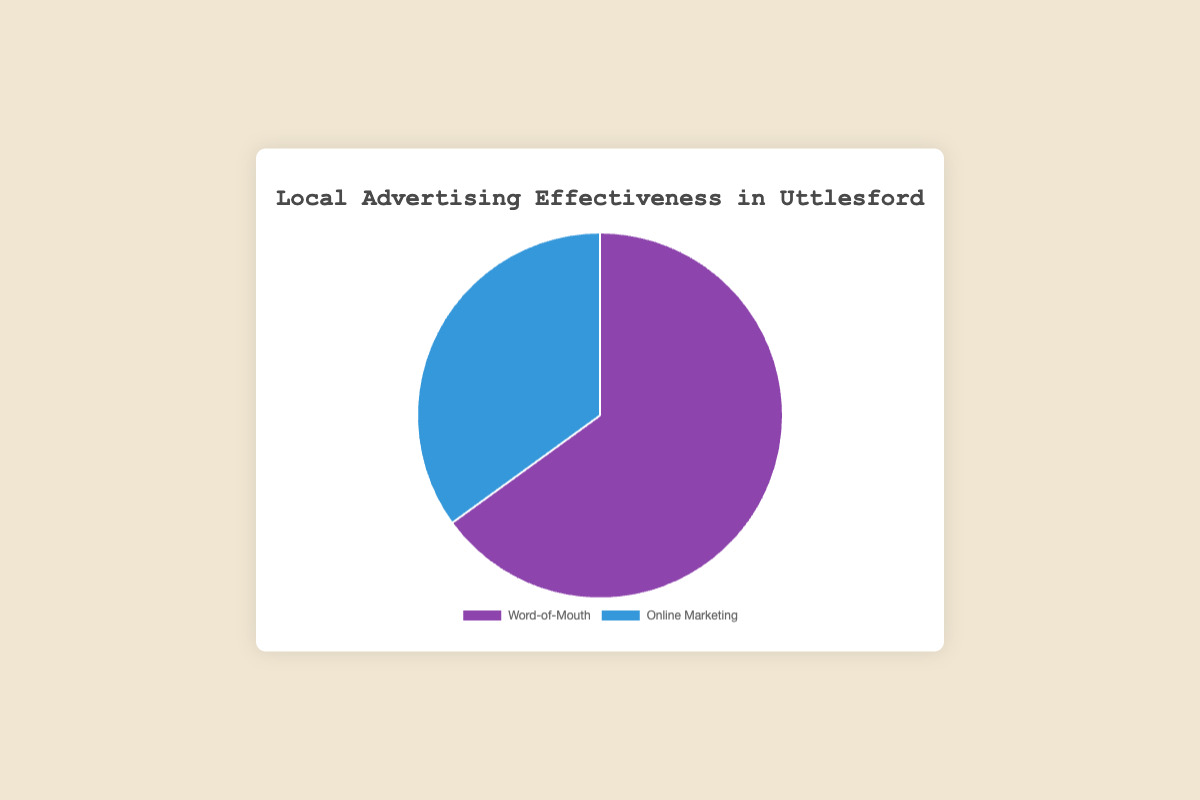What percentage of the effectiveness does Word-of-Mouth account for? The pie chart shows two categories: Word-of-Mouth and Online Marketing. Word-of-Mouth accounts for 65% of the effectiveness.
Answer: 65% How does the effectiveness of Online Marketing compare to Word-of-Mouth? The pie chart indicates that Online Marketing accounts for 35% of the effectiveness, while Word-of-Mouth accounts for 65%. So, Online Marketing is less effective.
Answer: Less effective Which form of local advertising is shown to be more effective? The pie chart indicates that Word-of-Mouth has a higher percentage of effectiveness (65%) compared to Online Marketing, which has 35%.
Answer: Word-of-Mouth How do the sizes of the pie slices for Word-of-Mouth and Online Marketing compare visually? The chart shows that the Word-of-Mouth slice is larger than the Online Marketing slice, indicating that Word-of-Mouth is more effective.
Answer: Word-of-Mouth slice is larger What is the combined effectiveness of Online Marketing and Personal Referrals? Online Marketing accounts for 35% effectiveness, and Personal Referrals account for 40% effectiveness under Word-of-Mouth. Combined, they account for 35% + 40% = 75% effectiveness.
Answer: 75% If you were to combine Community Events and Local Partnerships, how would their combined percentage compare to Google Ads? Community Events have a 15% effectiveness, and Local Partnerships have a 10% effectiveness. Together, they have 15% + 10% = 25%, which is higher compared to Google Ads, which have a 10% effectiveness.
Answer: 25% compared to 10% What visual characteristics differentiate the colors of the slices representing Word-of-Mouth and Online Marketing? The pie chart uses a specific color scheme where Word-of-Mouth is represented by a shade of purple, while Online Marketing is represented by a shade of blue.
Answer: Purple vs. Blue How does the effectiveness of social media ads compare to community events? Social Media Ads account for 20% effectiveness under Online Marketing, whereas Community Events account for 15% effectiveness under Word-of-Mouth. Social Media Ads are more effective.
Answer: Social Media Ads are more effective If Local Online Directories doubled their effectiveness, what new percentage effectiveness would Online Marketing have? Local Online Directories currently have a 5% effectiveness. Doubling this would make it 10%. Adding this to the existing 35% effectiveness of Online Marketing, the new effectiveness would be 35% + 5% = 40%.
Answer: 40% Which is more effective: the total of Online Marketing strategies or Personal Referrals alone? Online Marketing in total has 35% effectiveness. Personal Referrals alone have 40% effectiveness, which is higher than the total effectiveness of Online Marketing strategies.
Answer: Personal Referrals alone 